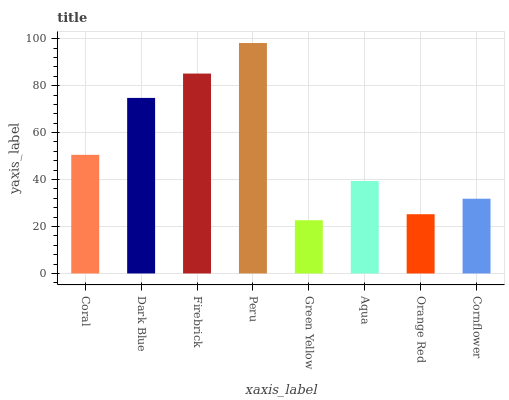Is Green Yellow the minimum?
Answer yes or no. Yes. Is Peru the maximum?
Answer yes or no. Yes. Is Dark Blue the minimum?
Answer yes or no. No. Is Dark Blue the maximum?
Answer yes or no. No. Is Dark Blue greater than Coral?
Answer yes or no. Yes. Is Coral less than Dark Blue?
Answer yes or no. Yes. Is Coral greater than Dark Blue?
Answer yes or no. No. Is Dark Blue less than Coral?
Answer yes or no. No. Is Coral the high median?
Answer yes or no. Yes. Is Aqua the low median?
Answer yes or no. Yes. Is Firebrick the high median?
Answer yes or no. No. Is Firebrick the low median?
Answer yes or no. No. 